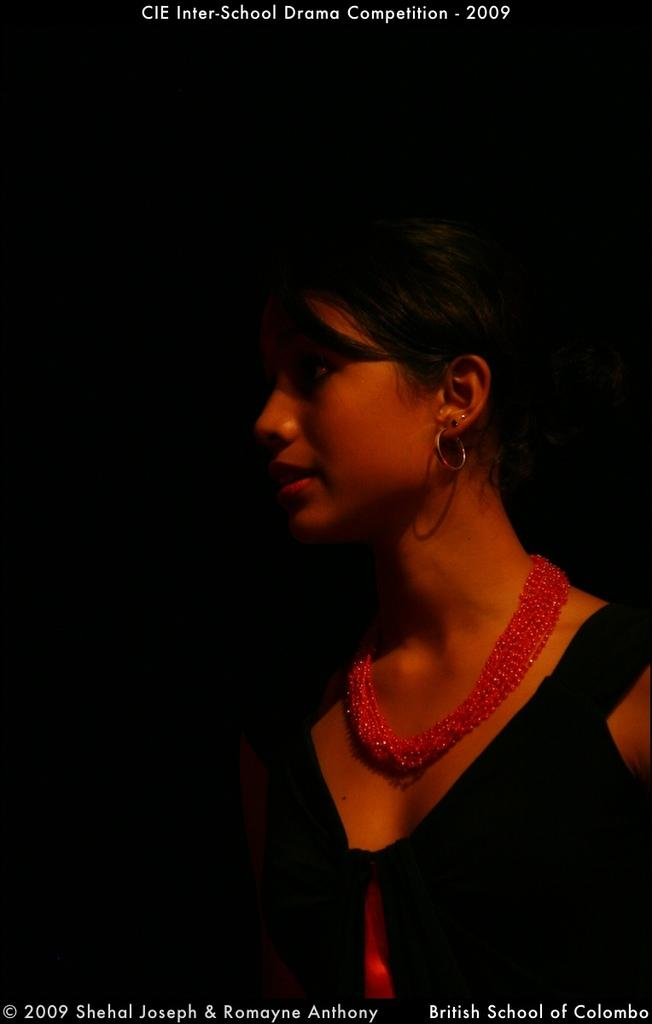What is the main subject of the image? The main subject of the image is a woman. Is there any text present in the image? Yes, there is text visible on the image. How many fairies are flying around the woman in the image? There are no fairies present in the image; it only features a woman and text. What type of flesh can be seen on the woman's body in the image? The image does not show any flesh or body parts of the woman; it only shows her as a whole subject. 